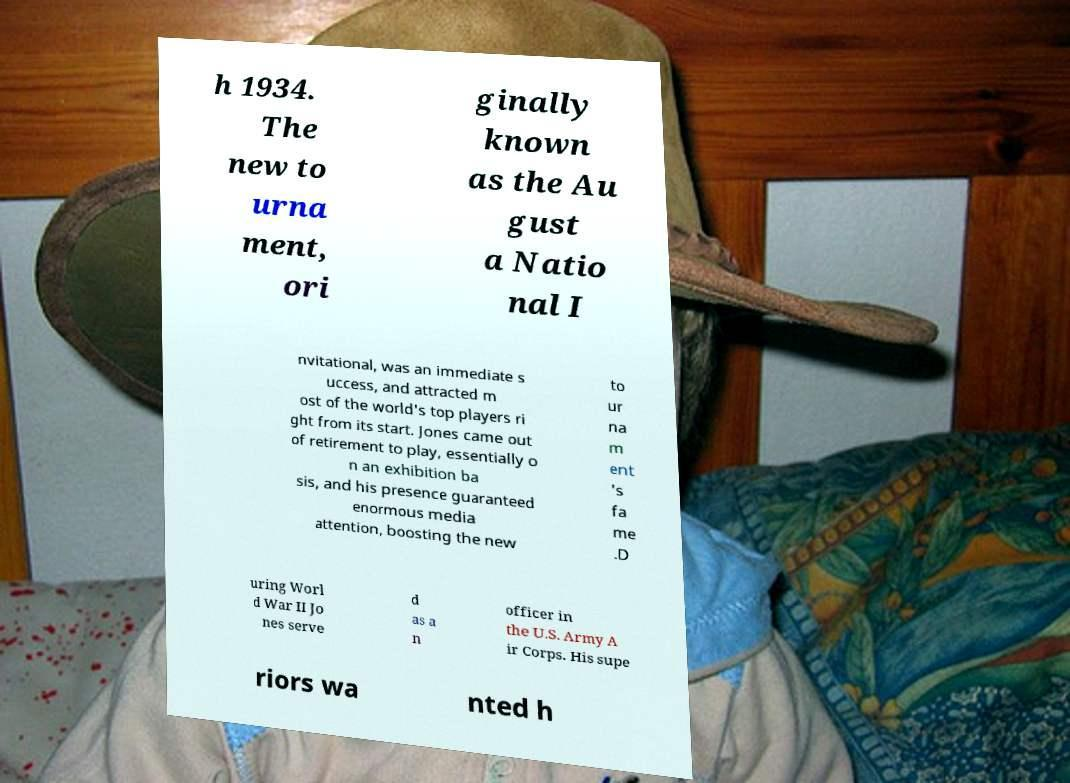Could you extract and type out the text from this image? h 1934. The new to urna ment, ori ginally known as the Au gust a Natio nal I nvitational, was an immediate s uccess, and attracted m ost of the world's top players ri ght from its start. Jones came out of retirement to play, essentially o n an exhibition ba sis, and his presence guaranteed enormous media attention, boosting the new to ur na m ent 's fa me .D uring Worl d War II Jo nes serve d as a n officer in the U.S. Army A ir Corps. His supe riors wa nted h 